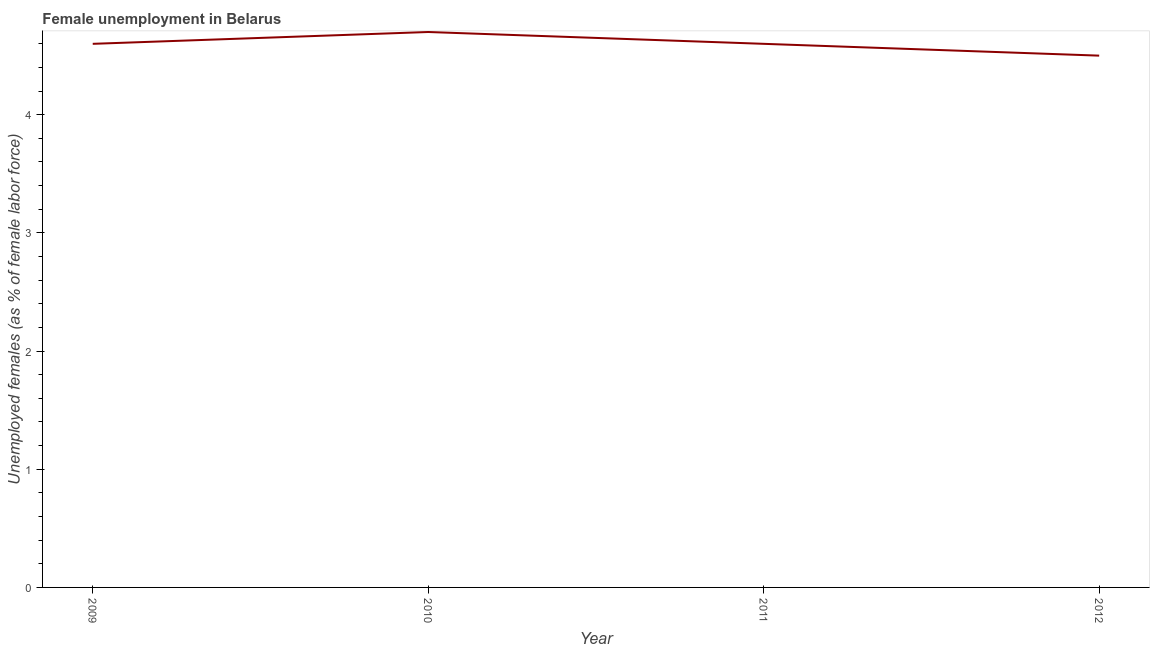What is the unemployed females population in 2010?
Your response must be concise. 4.7. Across all years, what is the maximum unemployed females population?
Keep it short and to the point. 4.7. Across all years, what is the minimum unemployed females population?
Provide a succinct answer. 4.5. What is the sum of the unemployed females population?
Your response must be concise. 18.4. What is the difference between the unemployed females population in 2011 and 2012?
Your answer should be compact. 0.1. What is the average unemployed females population per year?
Your answer should be compact. 4.6. What is the median unemployed females population?
Your response must be concise. 4.6. Do a majority of the years between 2009 and 2012 (inclusive) have unemployed females population greater than 4.4 %?
Your answer should be very brief. Yes. What is the difference between the highest and the second highest unemployed females population?
Provide a short and direct response. 0.1. What is the difference between the highest and the lowest unemployed females population?
Provide a succinct answer. 0.2. In how many years, is the unemployed females population greater than the average unemployed females population taken over all years?
Make the answer very short. 1. Does the unemployed females population monotonically increase over the years?
Keep it short and to the point. No. Does the graph contain any zero values?
Offer a terse response. No. What is the title of the graph?
Keep it short and to the point. Female unemployment in Belarus. What is the label or title of the X-axis?
Offer a very short reply. Year. What is the label or title of the Y-axis?
Your answer should be compact. Unemployed females (as % of female labor force). What is the Unemployed females (as % of female labor force) of 2009?
Provide a short and direct response. 4.6. What is the Unemployed females (as % of female labor force) of 2010?
Offer a terse response. 4.7. What is the Unemployed females (as % of female labor force) of 2011?
Keep it short and to the point. 4.6. What is the difference between the Unemployed females (as % of female labor force) in 2009 and 2011?
Ensure brevity in your answer.  0. What is the difference between the Unemployed females (as % of female labor force) in 2009 and 2012?
Your answer should be compact. 0.1. What is the difference between the Unemployed females (as % of female labor force) in 2011 and 2012?
Ensure brevity in your answer.  0.1. What is the ratio of the Unemployed females (as % of female labor force) in 2009 to that in 2010?
Make the answer very short. 0.98. What is the ratio of the Unemployed females (as % of female labor force) in 2009 to that in 2011?
Give a very brief answer. 1. What is the ratio of the Unemployed females (as % of female labor force) in 2009 to that in 2012?
Provide a short and direct response. 1.02. What is the ratio of the Unemployed females (as % of female labor force) in 2010 to that in 2012?
Your answer should be compact. 1.04. What is the ratio of the Unemployed females (as % of female labor force) in 2011 to that in 2012?
Your response must be concise. 1.02. 